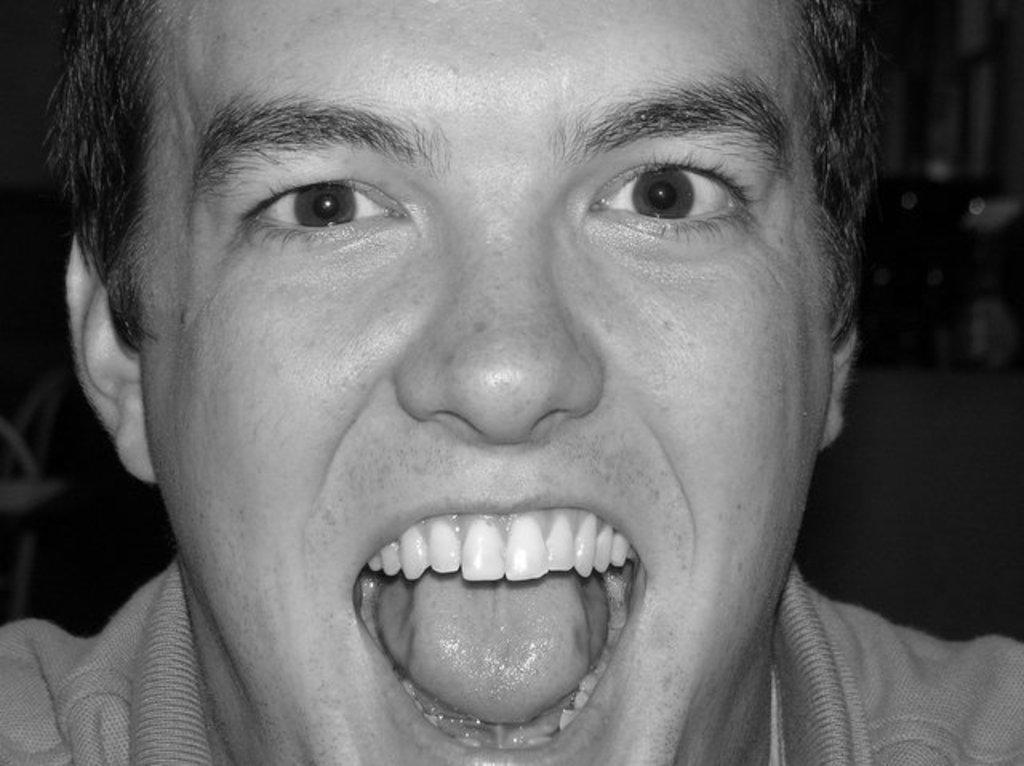How would you summarize this image in a sentence or two? It looks like a black and white picture. We can see a person's head. Behind the man there is the blurred background. 